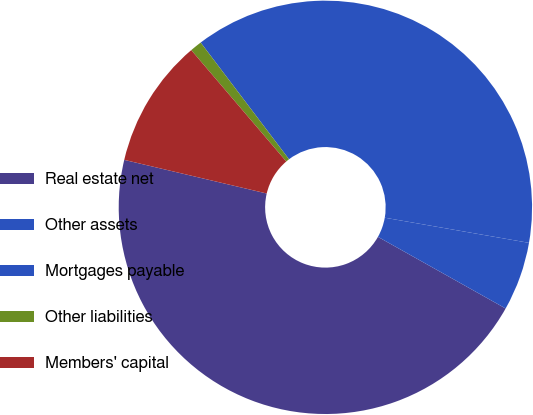Convert chart to OTSL. <chart><loc_0><loc_0><loc_500><loc_500><pie_chart><fcel>Real estate net<fcel>Other assets<fcel>Mortgages payable<fcel>Other liabilities<fcel>Members' capital<nl><fcel>45.55%<fcel>5.39%<fcel>38.06%<fcel>0.93%<fcel>10.07%<nl></chart> 